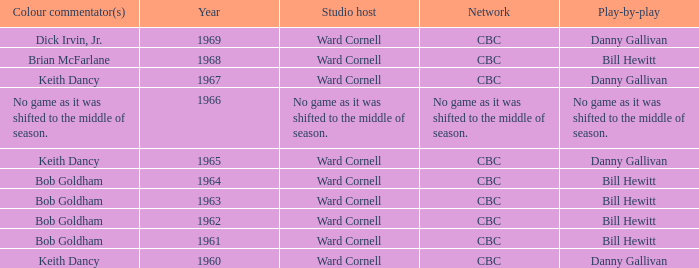Who did the play-by-play on the CBC network before 1961? Danny Gallivan. 